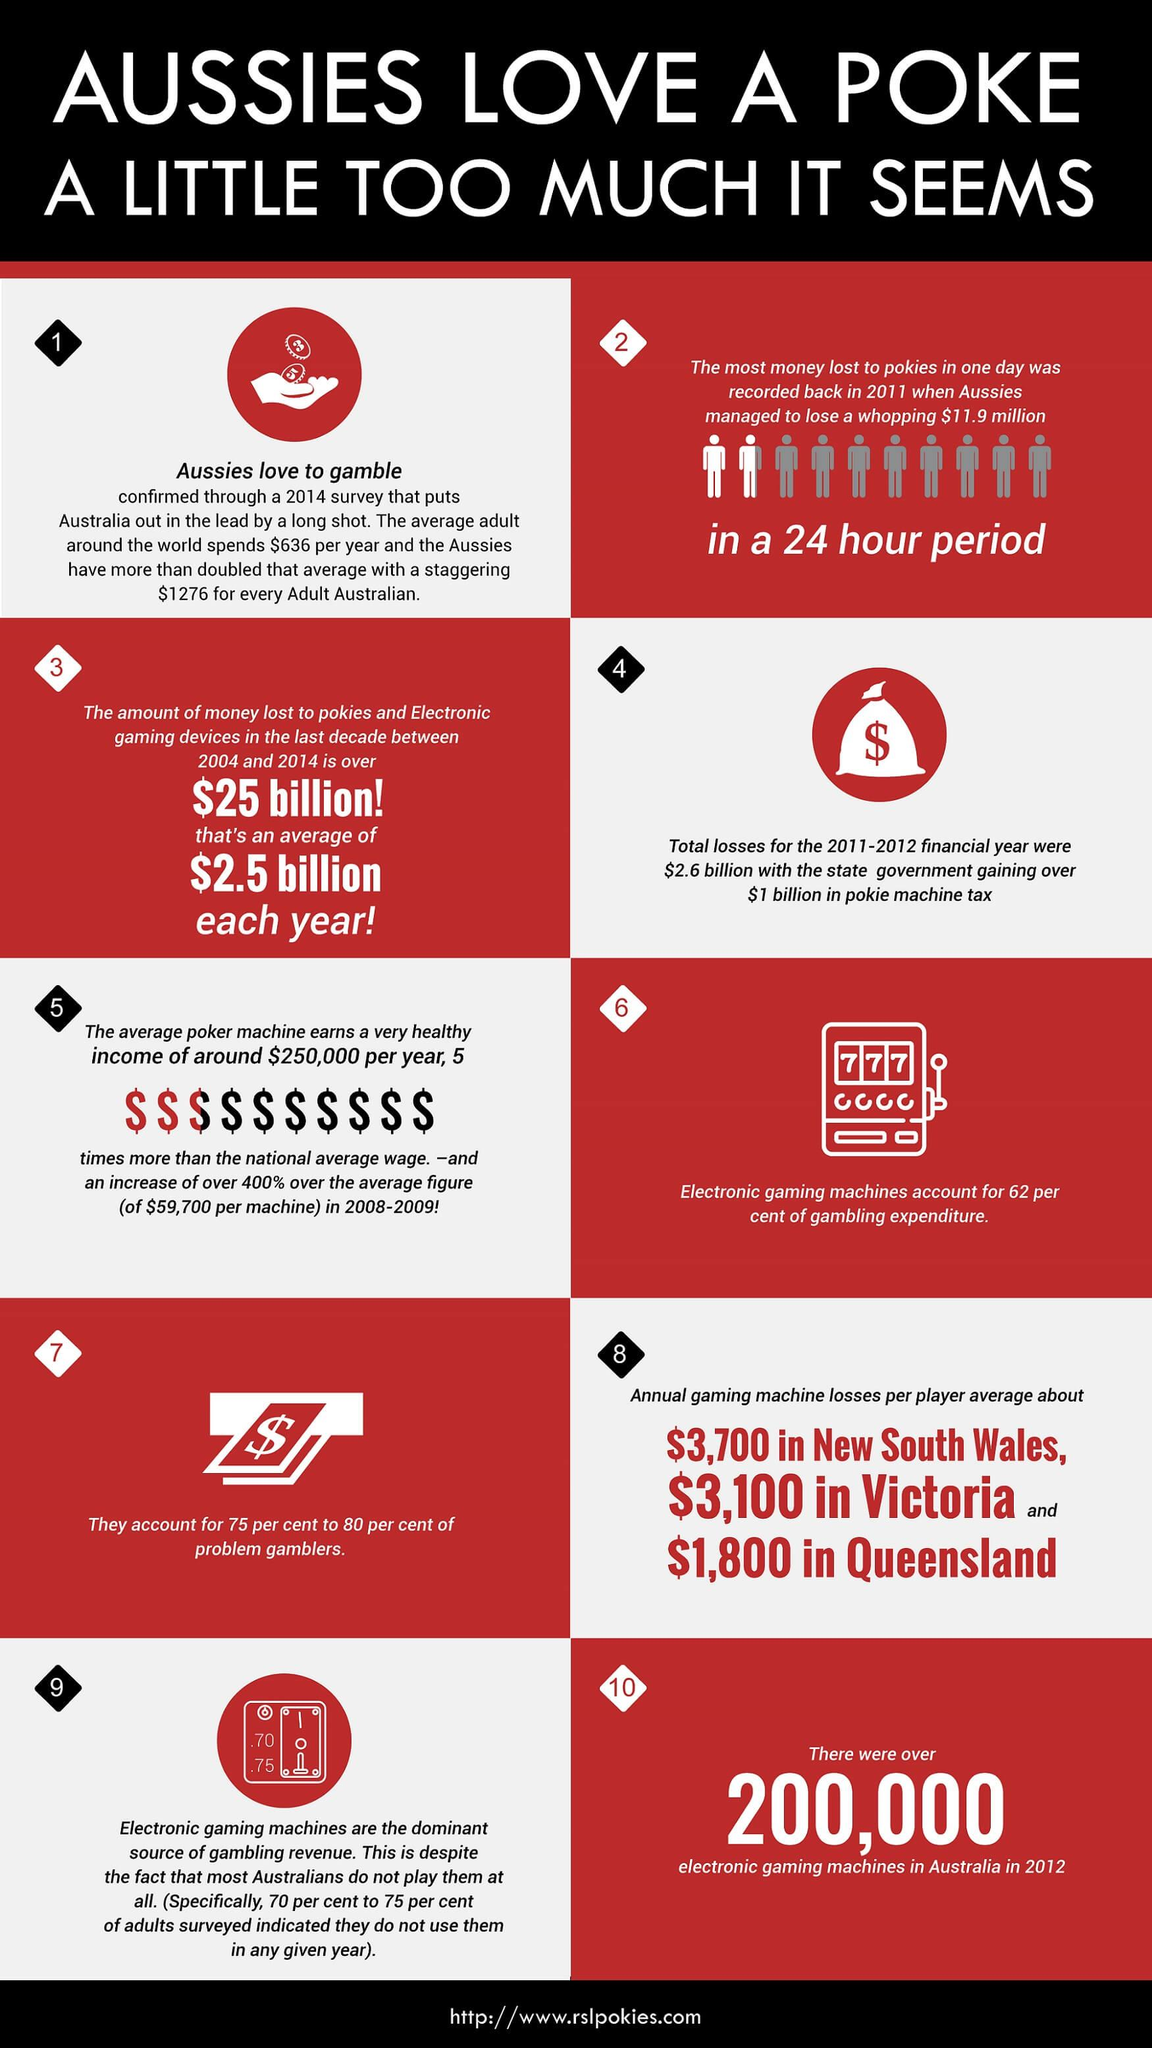Indicate a few pertinent items in this graphic. In computer programming, the dollar sign is typically used as a placeholder or variable name prefix to represent a variable of type "dollar" or "money." For example, the line of code "x = 10$" would assign the value 10 to the variable "x." The dollar sign is also used in string literals to represent the character "$" and to indicate the start of a hexadecimal number. For example, the string "0x$10" represents the decimal value 10. The game that is being discussed in the heading is 'Pokémon.' The average earnings per machine increased from 2008-2009 to 2014, from 19,0300 to... The highest amount lost in a 24-hour period was $11.9 million. There were approximately 4,900 total gaming machine losses in Victoria and Queensland in (year). 